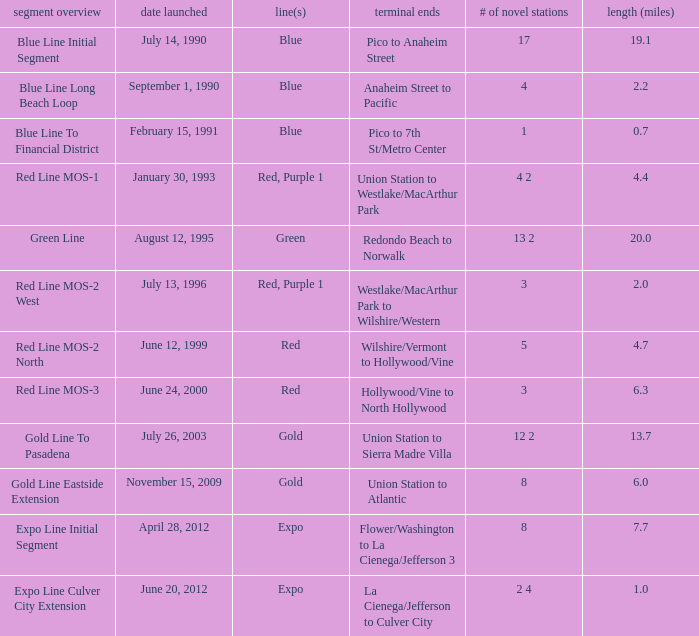How many new stations have a lenght (miles) of 6.0? 1.0. 